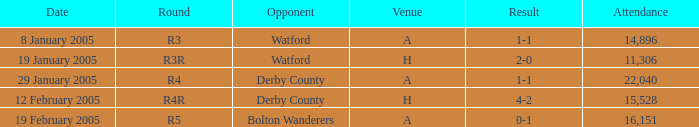What is the date where the round is R3? 8 January 2005. 